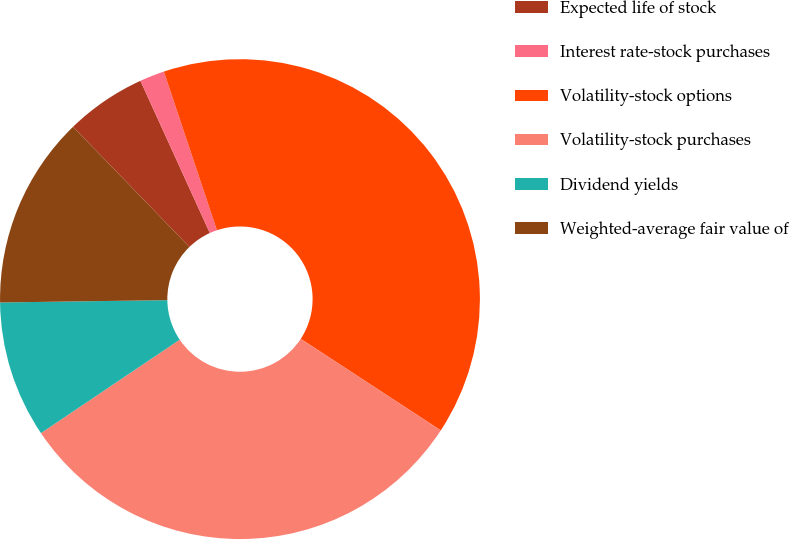<chart> <loc_0><loc_0><loc_500><loc_500><pie_chart><fcel>Expected life of stock<fcel>Interest rate-stock purchases<fcel>Volatility-stock options<fcel>Volatility-stock purchases<fcel>Dividend yields<fcel>Weighted-average fair value of<nl><fcel>5.44%<fcel>1.67%<fcel>39.36%<fcel>31.36%<fcel>9.21%<fcel>12.98%<nl></chart> 